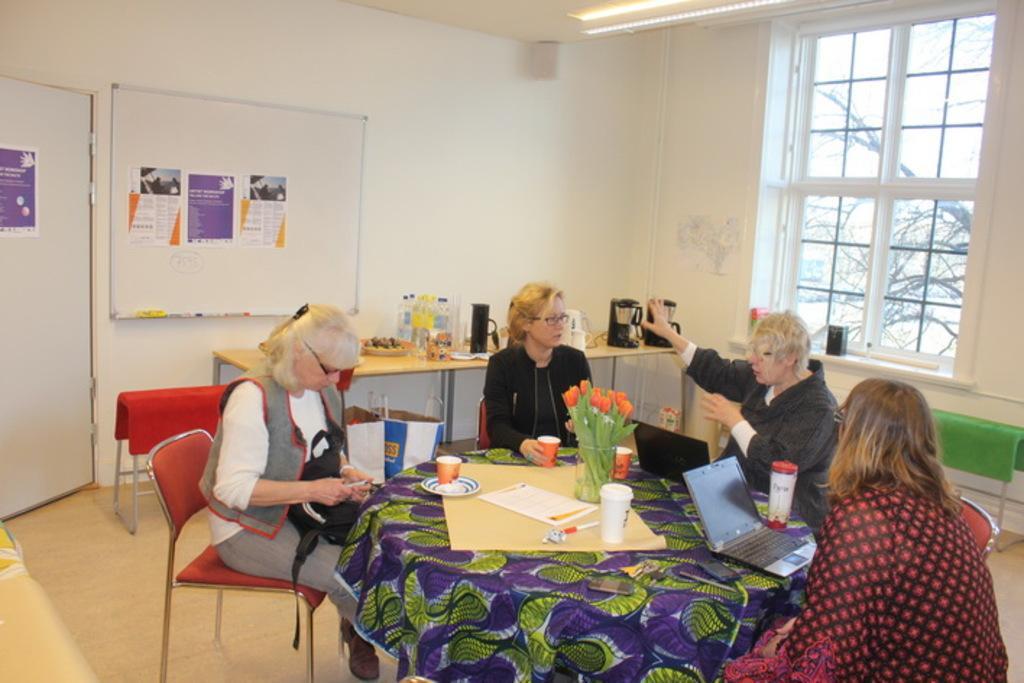Can you describe this image briefly? In this image I see 4 women who are sitting on the chairs and there is a table in front of them. On the table I see cups, laptops and a flower vase. In the background I see the window, wall, door and few papers on it and a table on which there are many things. 